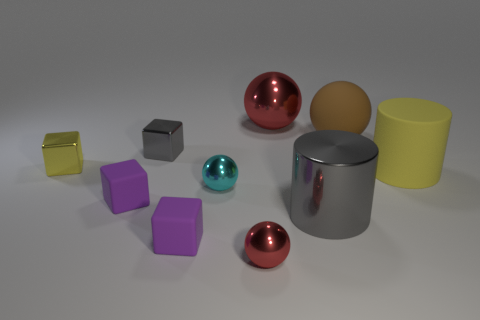Subtract all yellow metal cubes. How many cubes are left? 3 Subtract 2 balls. How many balls are left? 2 Subtract all green spheres. Subtract all red cylinders. How many spheres are left? 4 Subtract all green cylinders. How many cyan spheres are left? 1 Subtract all brown rubber things. Subtract all small red metal things. How many objects are left? 8 Add 4 gray metallic cylinders. How many gray metallic cylinders are left? 5 Add 1 metallic cylinders. How many metallic cylinders exist? 2 Subtract all cyan balls. How many balls are left? 3 Subtract 0 yellow balls. How many objects are left? 10 Subtract all blocks. How many objects are left? 6 